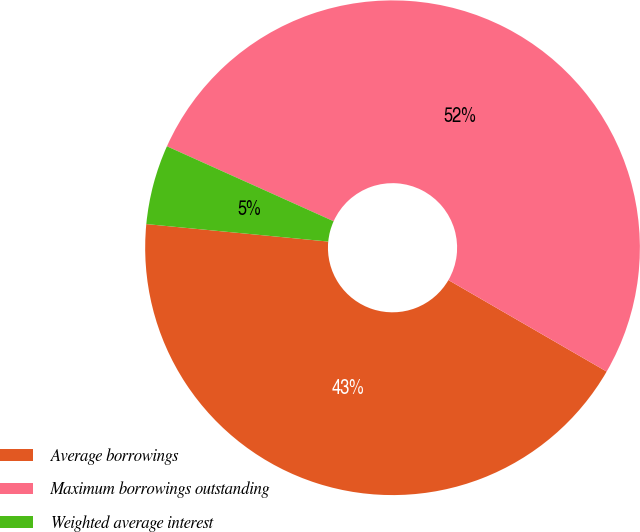Convert chart to OTSL. <chart><loc_0><loc_0><loc_500><loc_500><pie_chart><fcel>Average borrowings<fcel>Maximum borrowings outstanding<fcel>Weighted average interest<nl><fcel>43.18%<fcel>51.62%<fcel>5.2%<nl></chart> 